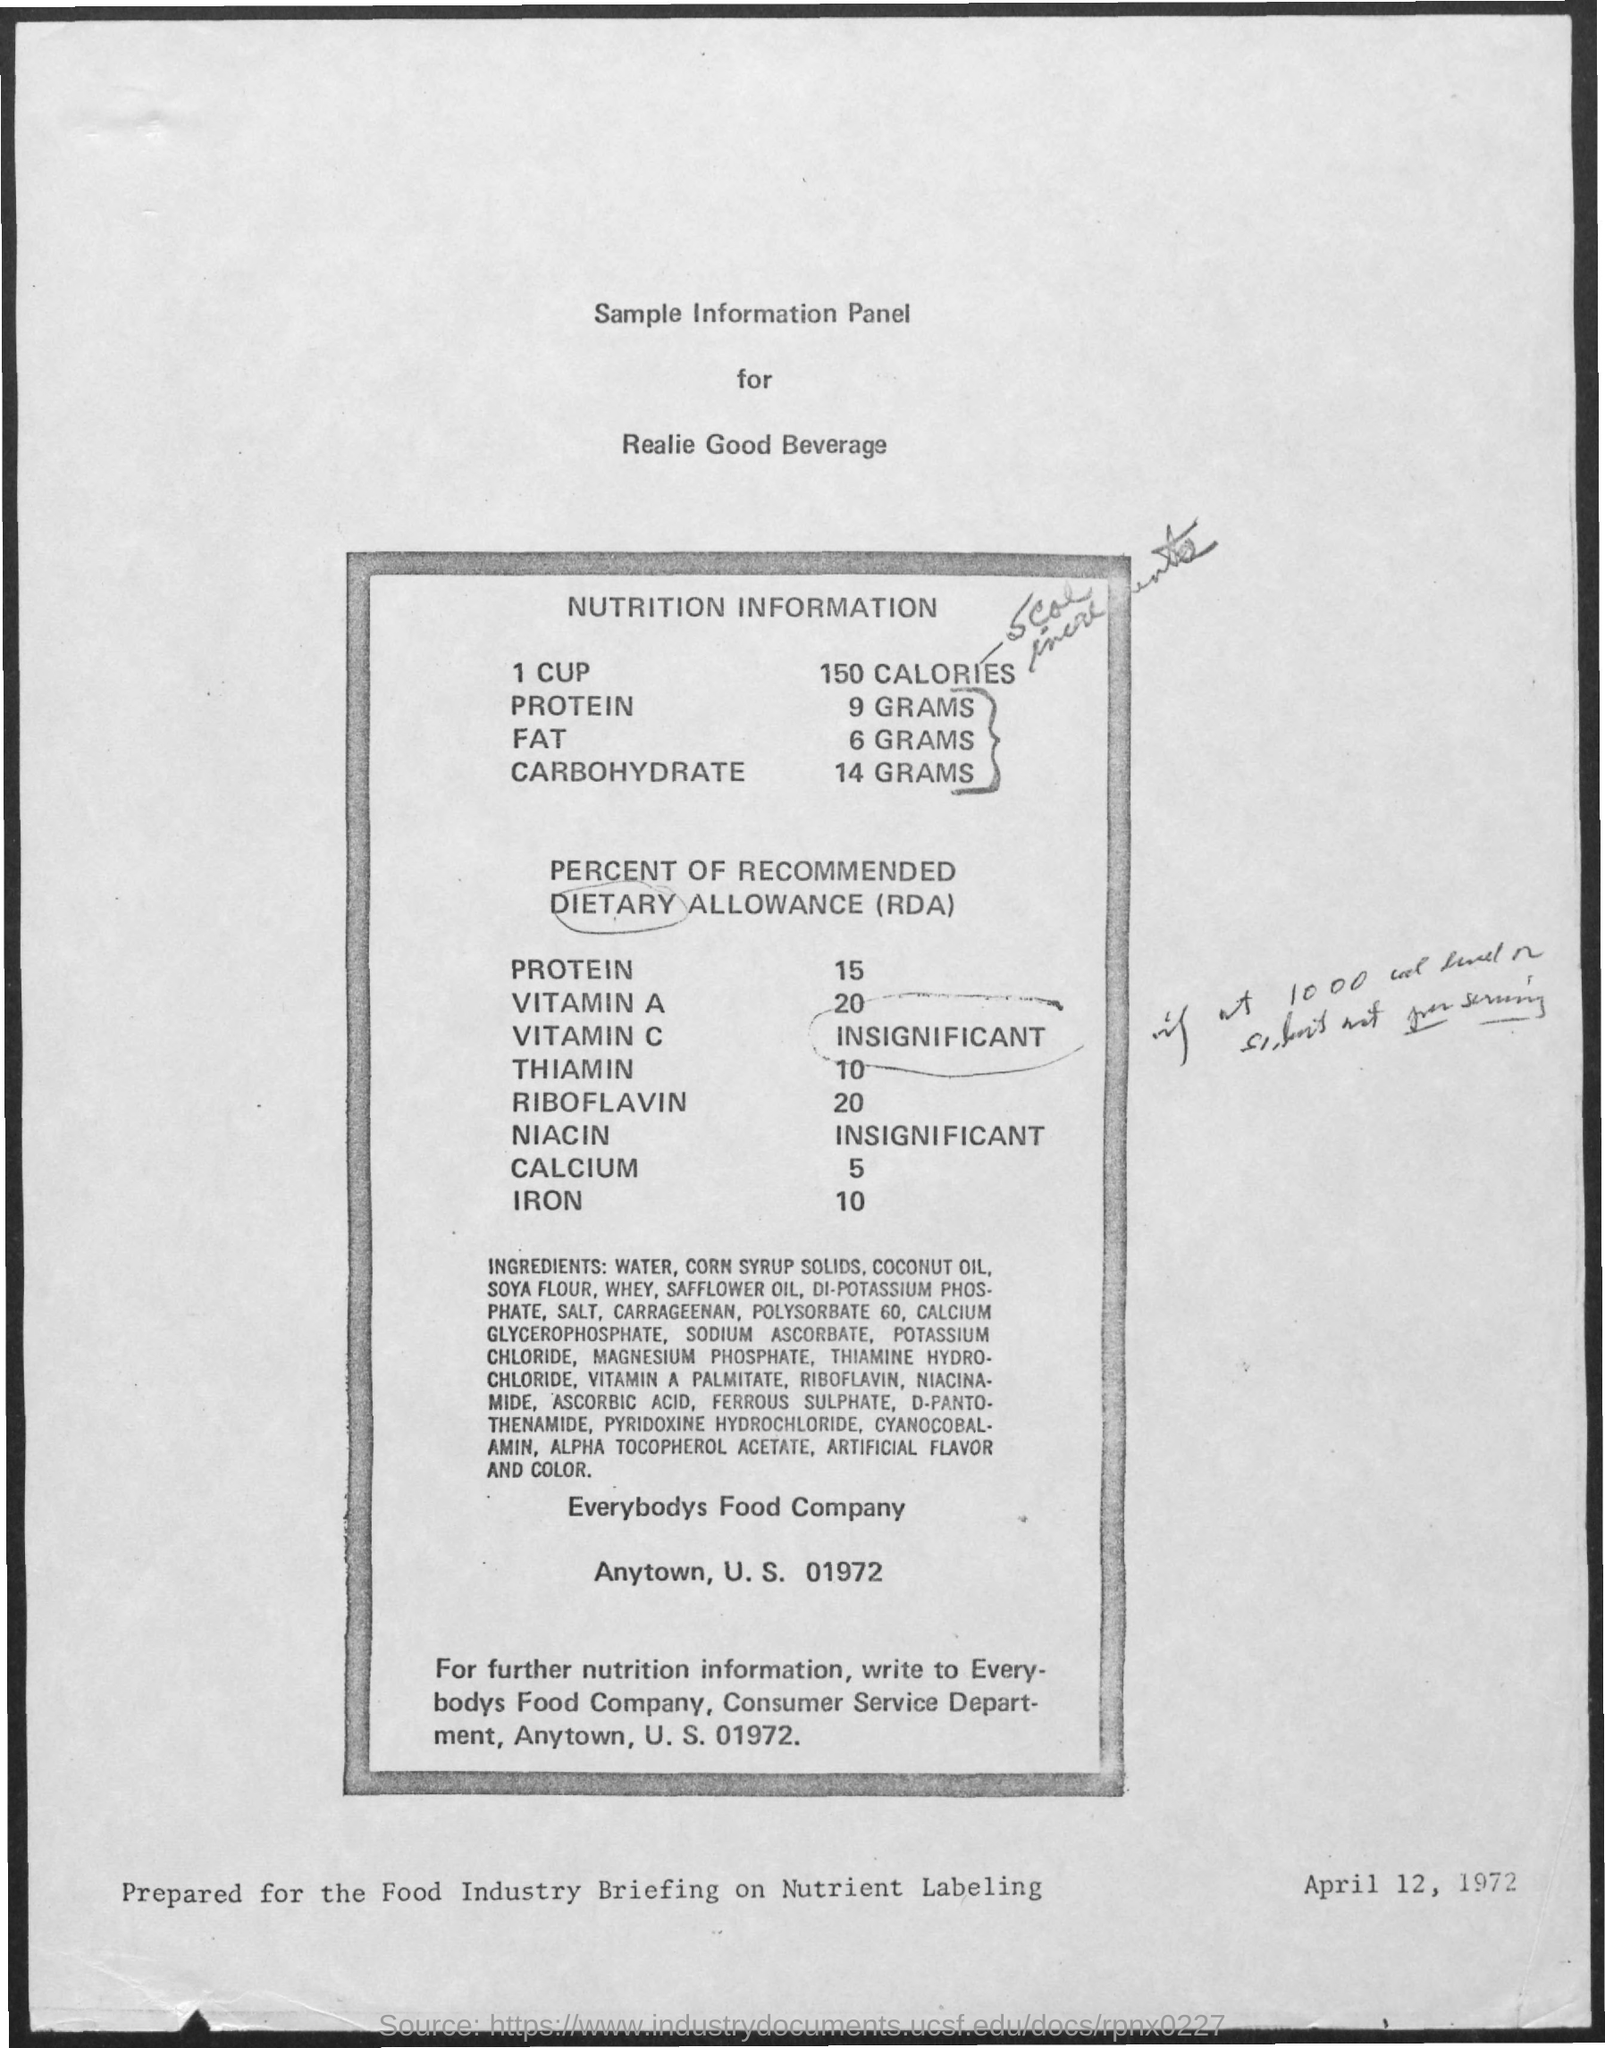Mention a couple of crucial points in this snapshot. This product contains 6 grams of fat. There are 150 calories in a cup. This product contains 9 grams of protein. This item contains 14 grams of carbohydrates. 